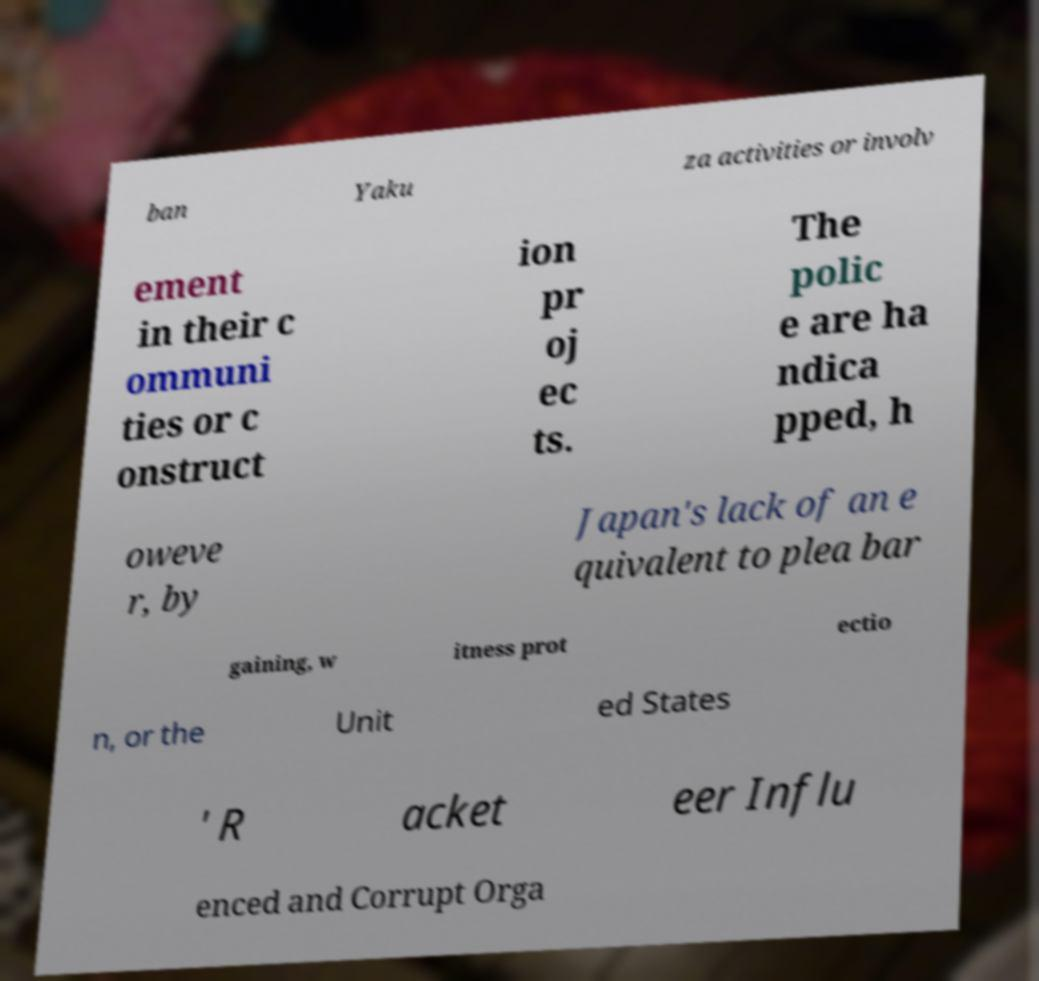Could you assist in decoding the text presented in this image and type it out clearly? ban Yaku za activities or involv ement in their c ommuni ties or c onstruct ion pr oj ec ts. The polic e are ha ndica pped, h oweve r, by Japan's lack of an e quivalent to plea bar gaining, w itness prot ectio n, or the Unit ed States ' R acket eer Influ enced and Corrupt Orga 